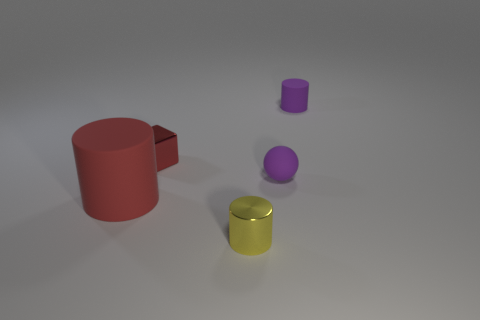Add 5 large brown shiny cylinders. How many objects exist? 10 Subtract all cylinders. How many objects are left? 2 Add 2 tiny rubber balls. How many tiny rubber balls are left? 3 Add 1 big red rubber cylinders. How many big red rubber cylinders exist? 2 Subtract 1 purple cylinders. How many objects are left? 4 Subtract all small purple spheres. Subtract all tiny purple things. How many objects are left? 2 